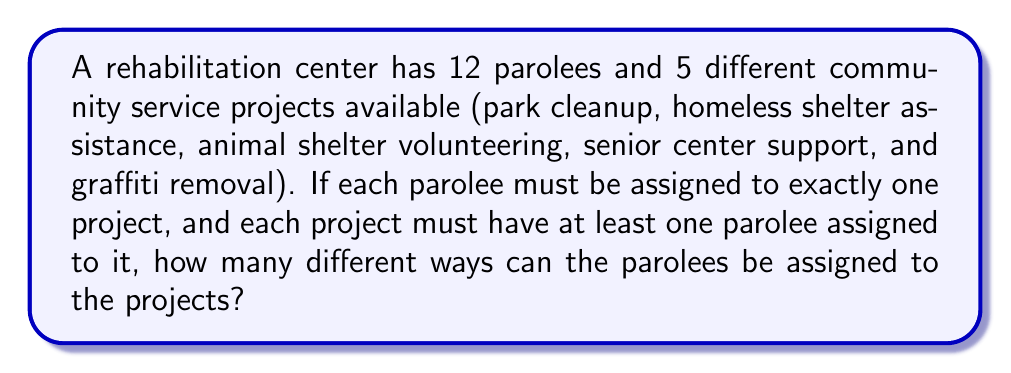Can you solve this math problem? To solve this problem, we can use the concept of Stirling numbers of the second kind and the multiplication principle.

1) First, we need to distribute 12 parolees among 5 projects, ensuring each project has at least one parolee. This is equivalent to partitioning a set of 12 elements into 5 non-empty subsets.

2) The number of ways to partition a set of n elements into k non-empty subsets is given by the Stirling number of the second kind, denoted as $\stirling{n}{k}$.

3) In this case, we need to calculate $\stirling{12}{5}$.

4) The formula for Stirling numbers of the second kind is:

   $$\stirling{n}{k} = \frac{1}{k!}\sum_{i=0}^k (-1)^i \binom{k}{i}(k-i)^n$$

5) Substituting our values:

   $$\stirling{12}{5} = \frac{1}{5!}\sum_{i=0}^5 (-1)^i \binom{5}{i}(5-i)^{12}$$

6) Expanding this:

   $$\stirling{12}{5} = \frac{1}{120}[5^{12} - 5\cdot4^{12} + 10\cdot3^{12} - 10\cdot2^{12} + 5\cdot1^{12}]$$

7) Calculating this gives us: $\stirling{12}{5} = 1,323,652$

8) However, this only tells us the number of ways to distribute the parolees. We also need to consider that within each distribution, the parolees can be arranged in different orders within their assigned projects.

9) For any given distribution, we can arrange the parolees within their projects in 12! ways.

10) Therefore, the total number of possible assignments is:

    $$1,323,652 \cdot 12! = 6,235,301,278,720$$
Answer: $6,235,301,278,720$ 